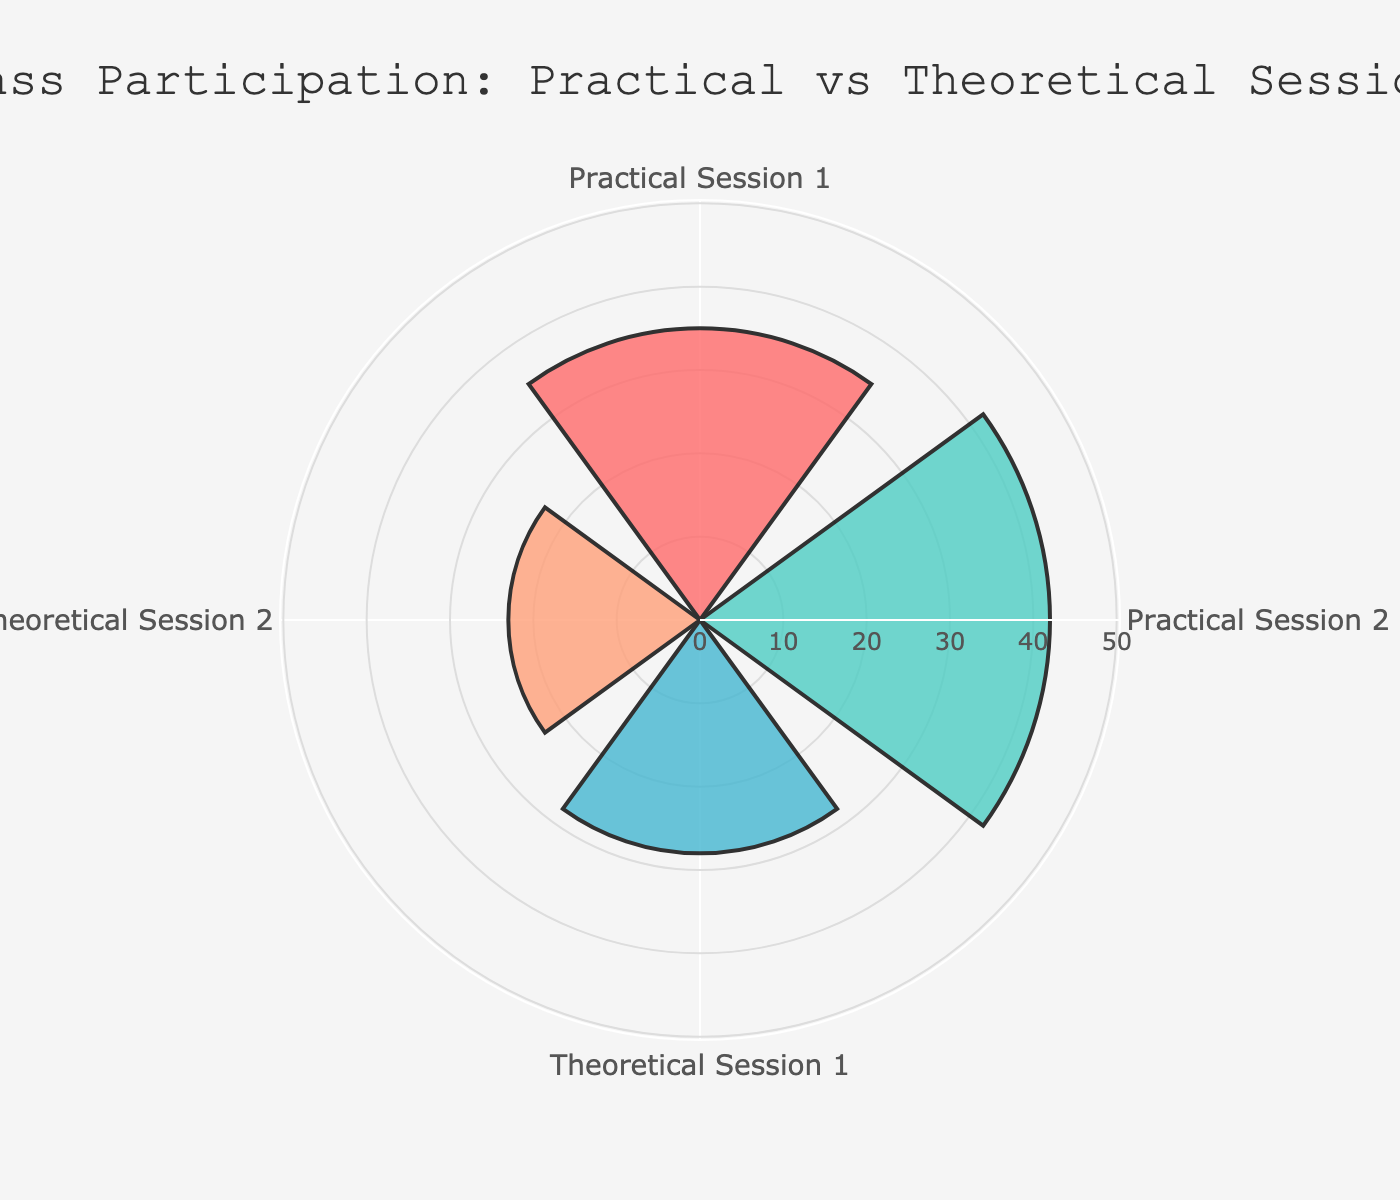Which session has the highest class participation? The segment representing "Practical Session 2" extends the farthest from the center, indicating the highest participation value.
Answer: Practical Session 2 What is the difference in class participation between "Practical Session 1" and "Theoretical Session 1"? "Practical Session 1" has 35 participants, while "Theoretical Session 1" has 28. Subtracting these, 35 - 28 = 7.
Answer: 7 How many more participants are there in "Practical Session 2" compared to "Theoretical Session 2"? "Practical Session 2" has 42 participants, and "Theoretical Session 2" has 23. The difference is 42 - 23 = 19.
Answer: 19 What is the sum of class participation across all sessions? Adding the values for all sessions: 35 + 42 + 28 + 23 = 128.
Answer: 128 Which session has the least class participation? The segment representing "Theoretical Session 2" is the shortest, indicating the lowest participation value.
Answer: Theoretical Session 2 What's the average class participation of the theoretical sessions? Sum the participants in the theoretical sessions (28 + 23) and divide by 2: (28 + 23) / 2 = 25.5.
Answer: 25.5 What is the rank of "Practical Session 1" in terms of class participation? Sorting the groups by participation: Practical Session 2 (42), Practical Session 1 (35), Theoretical Session 1 (28), Theoretical Session 2 (23). Practical Session 1 is second.
Answer: 2nd Are there more participants in practical sessions or theoretical sessions? Summing the participants in practical sessions: 35 + 42 = 77. Summing the participants in theoretical sessions: 28 + 23 = 51. Practical sessions have more participants.
Answer: Practical sessions 